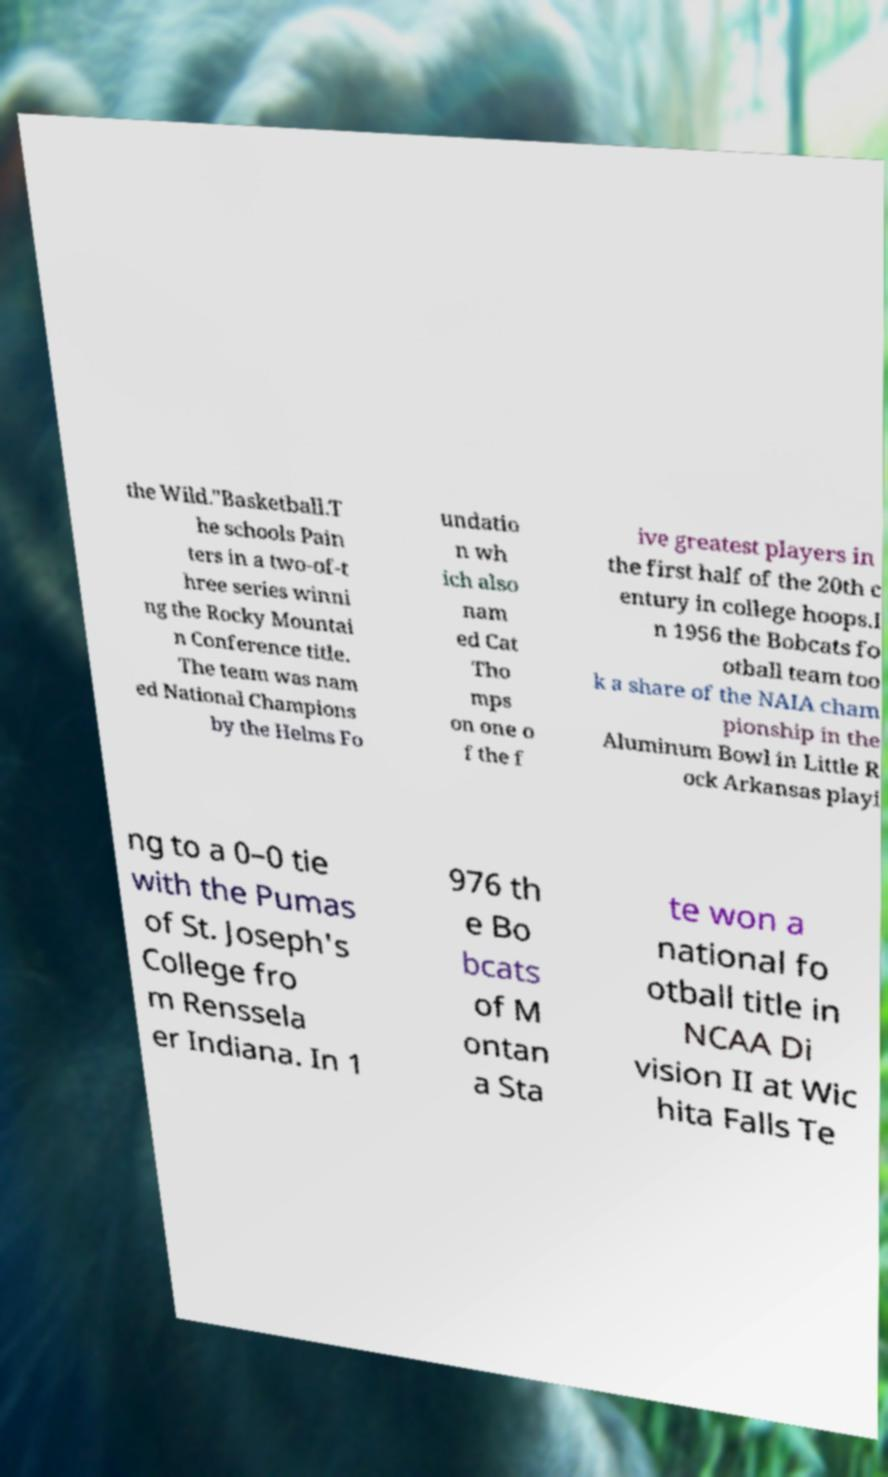Could you extract and type out the text from this image? the Wild."Basketball.T he schools Pain ters in a two-of-t hree series winni ng the Rocky Mountai n Conference title. The team was nam ed National Champions by the Helms Fo undatio n wh ich also nam ed Cat Tho mps on one o f the f ive greatest players in the first half of the 20th c entury in college hoops.I n 1956 the Bobcats fo otball team too k a share of the NAIA cham pionship in the Aluminum Bowl in Little R ock Arkansas playi ng to a 0–0 tie with the Pumas of St. Joseph's College fro m Renssela er Indiana. In 1 976 th e Bo bcats of M ontan a Sta te won a national fo otball title in NCAA Di vision II at Wic hita Falls Te 